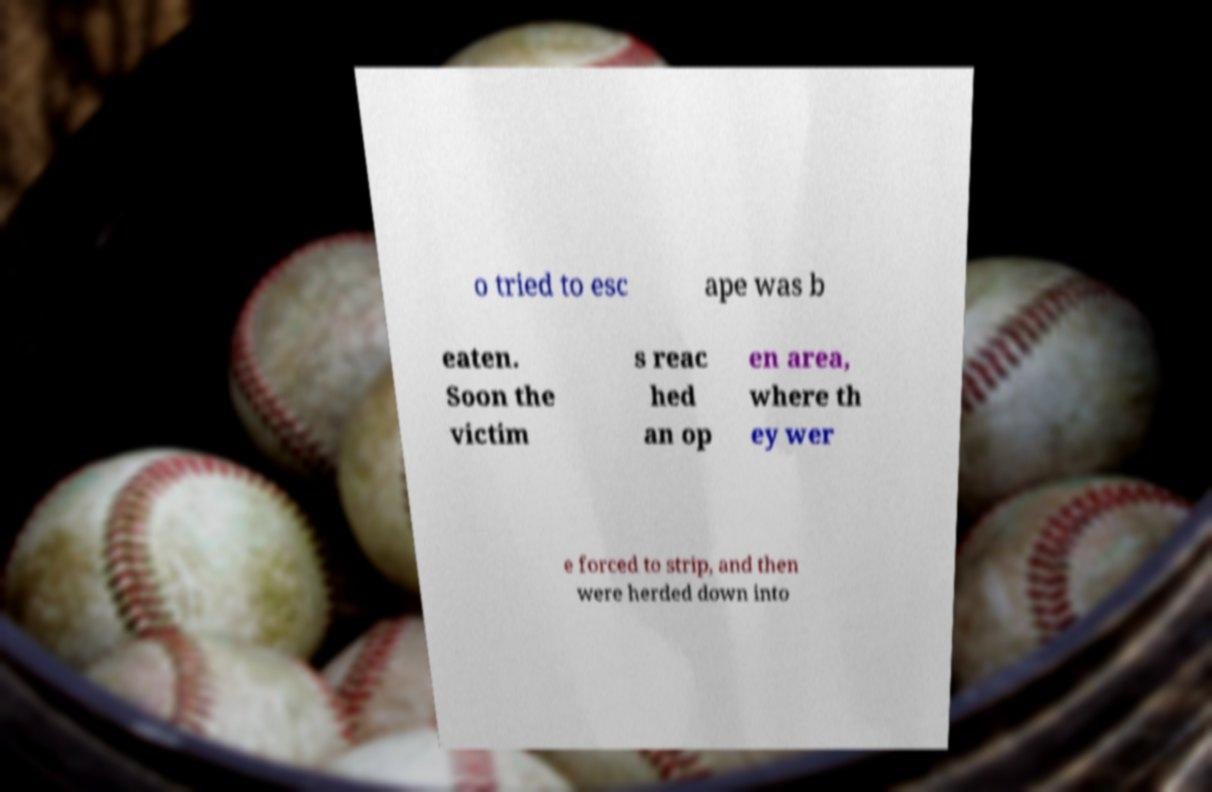For documentation purposes, I need the text within this image transcribed. Could you provide that? o tried to esc ape was b eaten. Soon the victim s reac hed an op en area, where th ey wer e forced to strip, and then were herded down into 